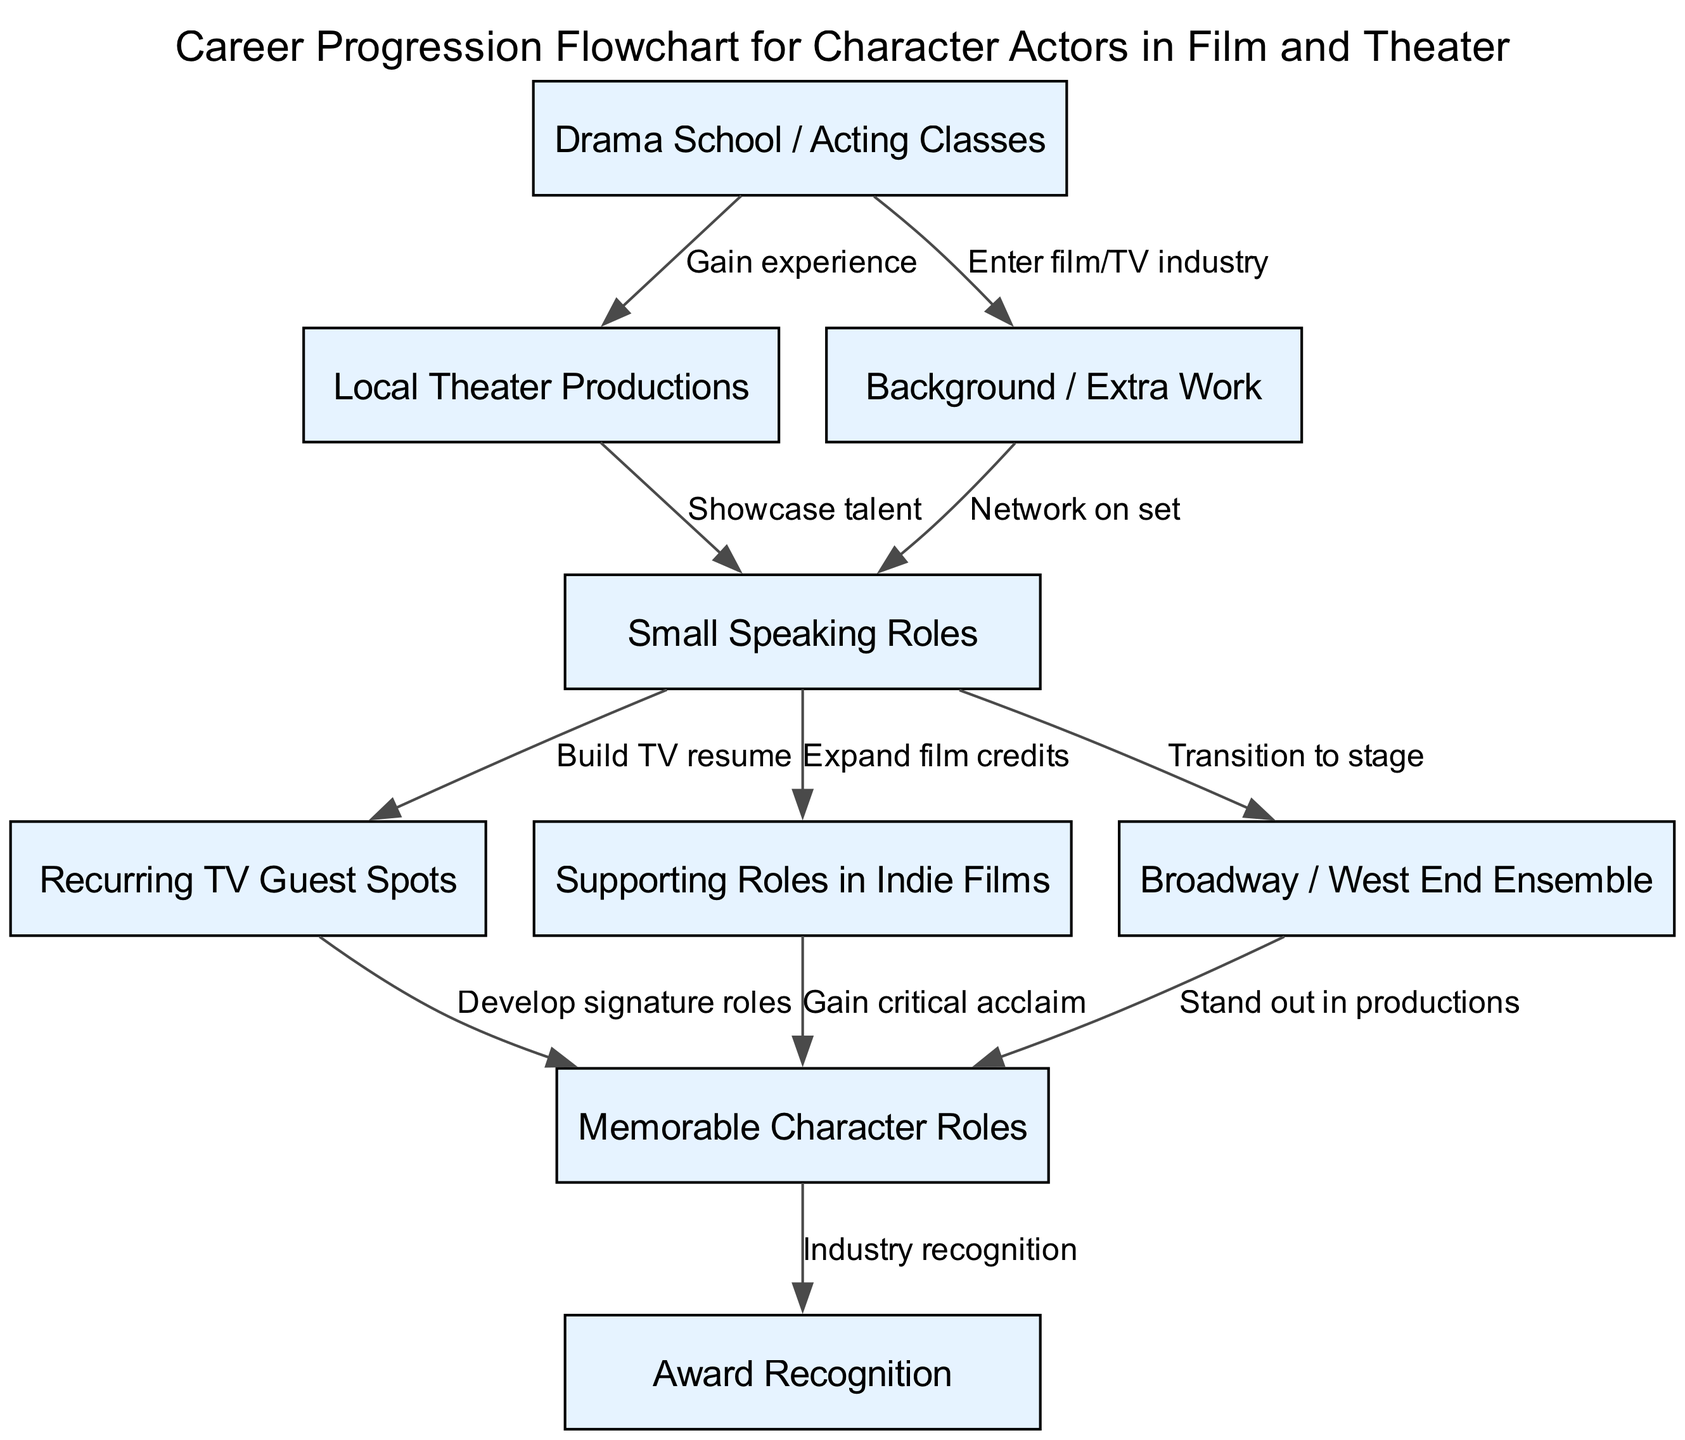What is the starting point for a character actor in the flowchart? The starting point is "Drama School / Acting Classes", which is the first node in the diagram.
Answer: Drama School / Acting Classes How many nodes are there in the diagram? Counting all the unique roles and experiences depicted, there are nine nodes in total.
Answer: 9 What role follows "Small Speaking Roles" in the progression? The flowchart indicates that "Small Speaking Roles" leads to both "Recurring TV Guest Spots" and "Supporting Roles in Indie Films", which are subsequent roles in the career progression.
Answer: Recurring TV Guest Spots, Supporting Roles in Indie Films What is the relationship between "Supporting Roles in Indie Films" and "Memorable Character Roles"? "Supporting Roles in Indie Films" leads to "Memorable Character Roles", indicating that performing in indie films can help an actor gain recognition for specific characters.
Answer: Gain critical acclaim Which node results in industry recognition? The diagram shows that "Memorable Character Roles" leads to "Award Recognition", which is the culmination of the career progression for a character actor.
Answer: Award Recognition What experience does one gain from "Local Theater Productions"? "Local Theater Productions" is linked to "Small Speaking Roles", suggesting that actors gain talent showcasing experience in local theaters.
Answer: Showcase talent How many edges connect to "Recurring TV Guest Spots"? There is one edge leading from "Small Speaking Roles" to "Recurring TV Guest Spots", indicating that this role builds on prior speaking experience.
Answer: 1 What is the final outcome for an actor who achieves "Memorable Character Roles"? Achieving "Memorable Character Roles" leads to "Award Recognition", indicating the ultimate acknowledgment for their work in the industry.
Answer: Award Recognition What leads to the "Broadway / West End Ensemble" node? "Small Speaking Roles" can transition to "Broadway / West End Ensemble", which showcases the potential for stage roles after gaining experience in smaller speaking parts.
Answer: Transition to stage 